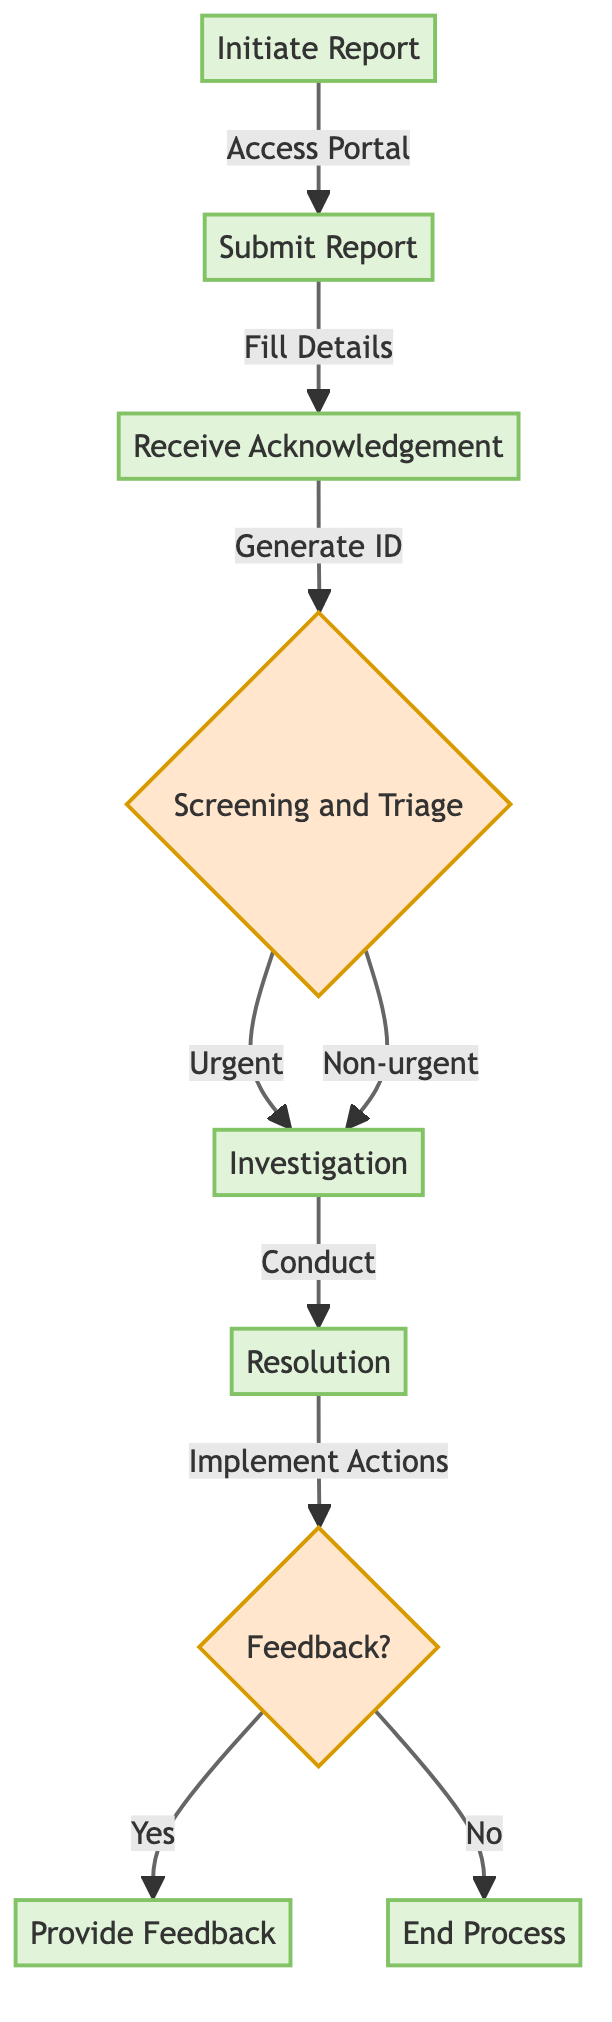What's the first step in the whistleblower reporting process? The diagram outlines the process starting with "Initiate Report," where the employee decides to report an issue and accesses the whistleblower portal. This is the first action taken in the workflow.
Answer: Initiate Report How many actions are involved in "Submit Report"? The "Submit Report" node includes a total of five actions: Fill Personal Details (optional), Describe Incident, Upload Supporting Evidence (optional), Choose Report Anonymity, and Submit Report. These actions are listed under this node.
Answer: Five actions What happens after the "Receive Acknowledgement" step? Following the "Receive Acknowledgement," the flowchart shows that the next step is "Screening and Triage," where the compliance team reviews the report for appropriateness. This directs the flow from acknowledging receipt to the screening process.
Answer: Screening and Triage How many options are there for handling the report during "Screening and Triage"? The diagram indicates that there are two possible paths after "Screening and Triage": the report can be classified as "Urgent" or "Non-urgent," representing two options for prioritization.
Answer: Two options If a report is marked as urgent, what is the next step? If a report is classified as urgent, the next step in the flowchart is "Investigation," indicating that it will be handled without delay for further inquiry. This follows the action of screening and prioritizing the report.
Answer: Investigation What is the final decision point in the process? The final point of decision in the flowchart is the "Feedback?" decision node which asks whether feedback will be given to the whistleblower. This node determines if the process concludes with feedback or ends without it.
Answer: Feedback? What is done if the report is investigated? Once the investigation is carried out, the flowchart leads to the "Resolution" node, indicating that appropriate actions will be determined and implemented based on the findings from the investigation so it shows the next logical step after an investigation.
Answer: Resolution Is feedback mandatory for all reports? The flowchart specifies that feedback is only provided if the whistleblower is not anonymous, creating a conditional pathway based on the whistleblower's choice of anonymity. This indicates that feedback is not mandatory for all reports.
Answer: No 